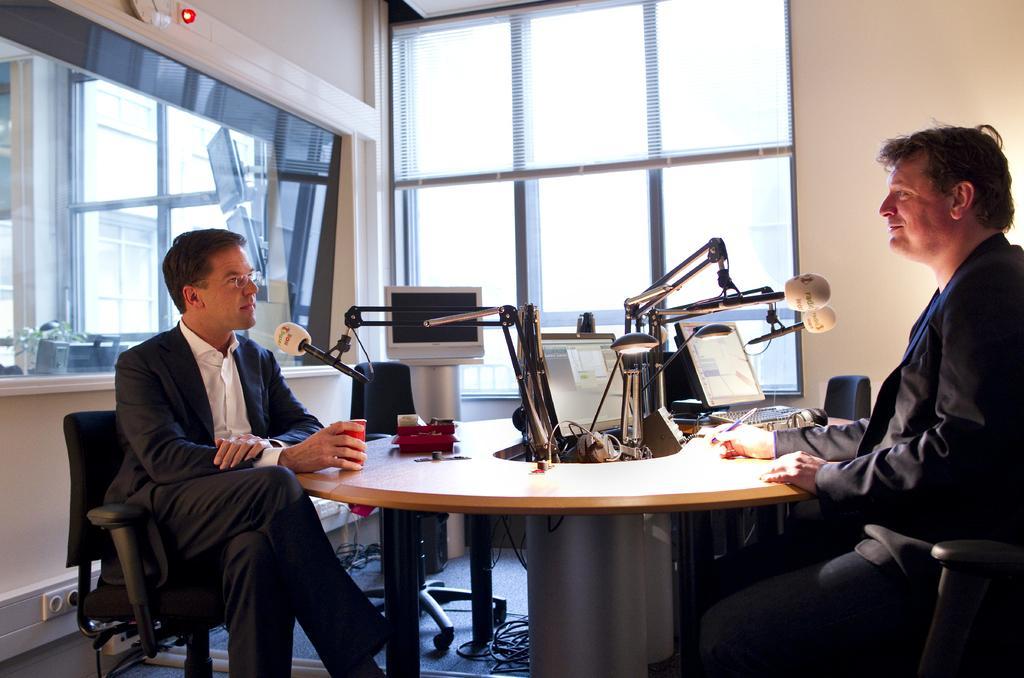Could you give a brief overview of what you see in this image? Two persons are sitting on the chairs holding their hands on a table. Here it's a light in the middle of an image there is a glass window. 